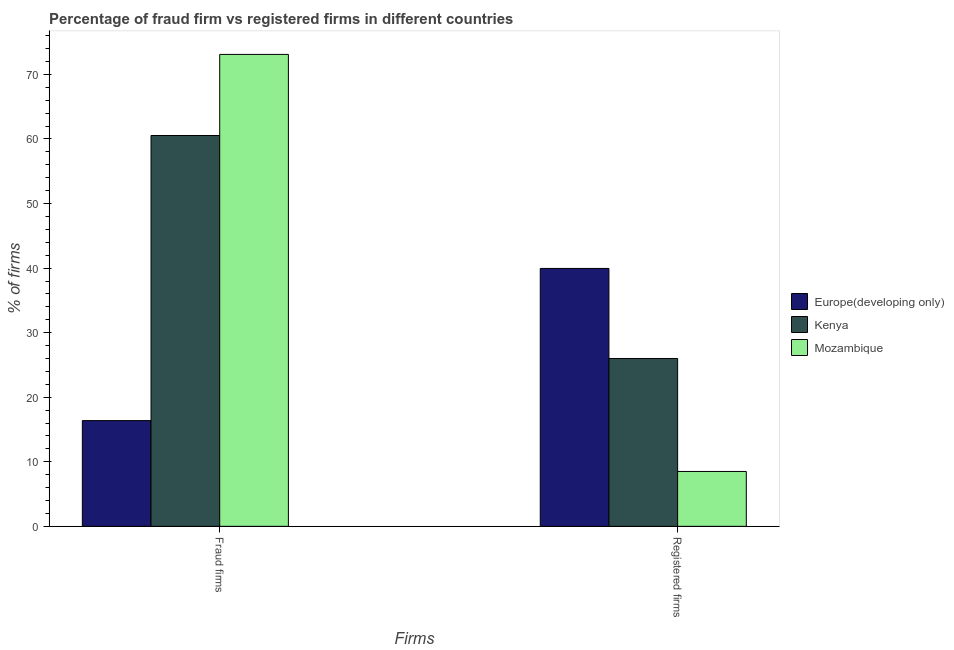How many different coloured bars are there?
Your response must be concise. 3. How many bars are there on the 2nd tick from the right?
Your answer should be very brief. 3. What is the label of the 1st group of bars from the left?
Offer a very short reply. Fraud firms. What is the percentage of registered firms in Europe(developing only)?
Provide a succinct answer. 39.95. Across all countries, what is the maximum percentage of registered firms?
Provide a short and direct response. 39.95. In which country was the percentage of registered firms maximum?
Your answer should be compact. Europe(developing only). In which country was the percentage of registered firms minimum?
Provide a succinct answer. Mozambique. What is the total percentage of registered firms in the graph?
Offer a very short reply. 74.45. What is the difference between the percentage of registered firms in Mozambique and that in Kenya?
Offer a terse response. -17.5. What is the difference between the percentage of registered firms in Kenya and the percentage of fraud firms in Europe(developing only)?
Provide a succinct answer. 9.62. What is the average percentage of registered firms per country?
Ensure brevity in your answer.  24.82. What is the difference between the percentage of fraud firms and percentage of registered firms in Kenya?
Keep it short and to the point. 34.54. What is the ratio of the percentage of fraud firms in Europe(developing only) to that in Kenya?
Make the answer very short. 0.27. Is the percentage of registered firms in Kenya less than that in Europe(developing only)?
Provide a short and direct response. Yes. What does the 2nd bar from the left in Fraud firms represents?
Your response must be concise. Kenya. What does the 1st bar from the right in Fraud firms represents?
Offer a terse response. Mozambique. Are all the bars in the graph horizontal?
Provide a succinct answer. No. How many countries are there in the graph?
Your answer should be compact. 3. What is the difference between two consecutive major ticks on the Y-axis?
Provide a short and direct response. 10. Are the values on the major ticks of Y-axis written in scientific E-notation?
Your answer should be compact. No. Does the graph contain any zero values?
Provide a succinct answer. No. Where does the legend appear in the graph?
Offer a terse response. Center right. How are the legend labels stacked?
Provide a succinct answer. Vertical. What is the title of the graph?
Make the answer very short. Percentage of fraud firm vs registered firms in different countries. What is the label or title of the X-axis?
Your response must be concise. Firms. What is the label or title of the Y-axis?
Offer a terse response. % of firms. What is the % of firms in Europe(developing only) in Fraud firms?
Keep it short and to the point. 16.38. What is the % of firms of Kenya in Fraud firms?
Offer a terse response. 60.54. What is the % of firms of Mozambique in Fraud firms?
Your response must be concise. 73.1. What is the % of firms in Europe(developing only) in Registered firms?
Make the answer very short. 39.95. What is the % of firms in Mozambique in Registered firms?
Offer a very short reply. 8.5. Across all Firms, what is the maximum % of firms in Europe(developing only)?
Your answer should be compact. 39.95. Across all Firms, what is the maximum % of firms in Kenya?
Your answer should be very brief. 60.54. Across all Firms, what is the maximum % of firms in Mozambique?
Your answer should be compact. 73.1. Across all Firms, what is the minimum % of firms of Europe(developing only)?
Your response must be concise. 16.38. Across all Firms, what is the minimum % of firms in Mozambique?
Offer a terse response. 8.5. What is the total % of firms of Europe(developing only) in the graph?
Your answer should be very brief. 56.33. What is the total % of firms of Kenya in the graph?
Ensure brevity in your answer.  86.54. What is the total % of firms in Mozambique in the graph?
Offer a very short reply. 81.6. What is the difference between the % of firms in Europe(developing only) in Fraud firms and that in Registered firms?
Keep it short and to the point. -23.57. What is the difference between the % of firms in Kenya in Fraud firms and that in Registered firms?
Offer a terse response. 34.54. What is the difference between the % of firms in Mozambique in Fraud firms and that in Registered firms?
Give a very brief answer. 64.6. What is the difference between the % of firms in Europe(developing only) in Fraud firms and the % of firms in Kenya in Registered firms?
Keep it short and to the point. -9.62. What is the difference between the % of firms of Europe(developing only) in Fraud firms and the % of firms of Mozambique in Registered firms?
Offer a terse response. 7.88. What is the difference between the % of firms of Kenya in Fraud firms and the % of firms of Mozambique in Registered firms?
Provide a short and direct response. 52.04. What is the average % of firms in Europe(developing only) per Firms?
Ensure brevity in your answer.  28.16. What is the average % of firms of Kenya per Firms?
Your response must be concise. 43.27. What is the average % of firms of Mozambique per Firms?
Your response must be concise. 40.8. What is the difference between the % of firms of Europe(developing only) and % of firms of Kenya in Fraud firms?
Ensure brevity in your answer.  -44.16. What is the difference between the % of firms in Europe(developing only) and % of firms in Mozambique in Fraud firms?
Ensure brevity in your answer.  -56.72. What is the difference between the % of firms of Kenya and % of firms of Mozambique in Fraud firms?
Provide a short and direct response. -12.56. What is the difference between the % of firms of Europe(developing only) and % of firms of Kenya in Registered firms?
Ensure brevity in your answer.  13.95. What is the difference between the % of firms in Europe(developing only) and % of firms in Mozambique in Registered firms?
Provide a short and direct response. 31.45. What is the difference between the % of firms of Kenya and % of firms of Mozambique in Registered firms?
Give a very brief answer. 17.5. What is the ratio of the % of firms in Europe(developing only) in Fraud firms to that in Registered firms?
Provide a succinct answer. 0.41. What is the ratio of the % of firms in Kenya in Fraud firms to that in Registered firms?
Your response must be concise. 2.33. What is the ratio of the % of firms of Mozambique in Fraud firms to that in Registered firms?
Your response must be concise. 8.6. What is the difference between the highest and the second highest % of firms of Europe(developing only)?
Offer a very short reply. 23.57. What is the difference between the highest and the second highest % of firms of Kenya?
Provide a short and direct response. 34.54. What is the difference between the highest and the second highest % of firms in Mozambique?
Keep it short and to the point. 64.6. What is the difference between the highest and the lowest % of firms in Europe(developing only)?
Your answer should be very brief. 23.57. What is the difference between the highest and the lowest % of firms in Kenya?
Your answer should be compact. 34.54. What is the difference between the highest and the lowest % of firms in Mozambique?
Ensure brevity in your answer.  64.6. 